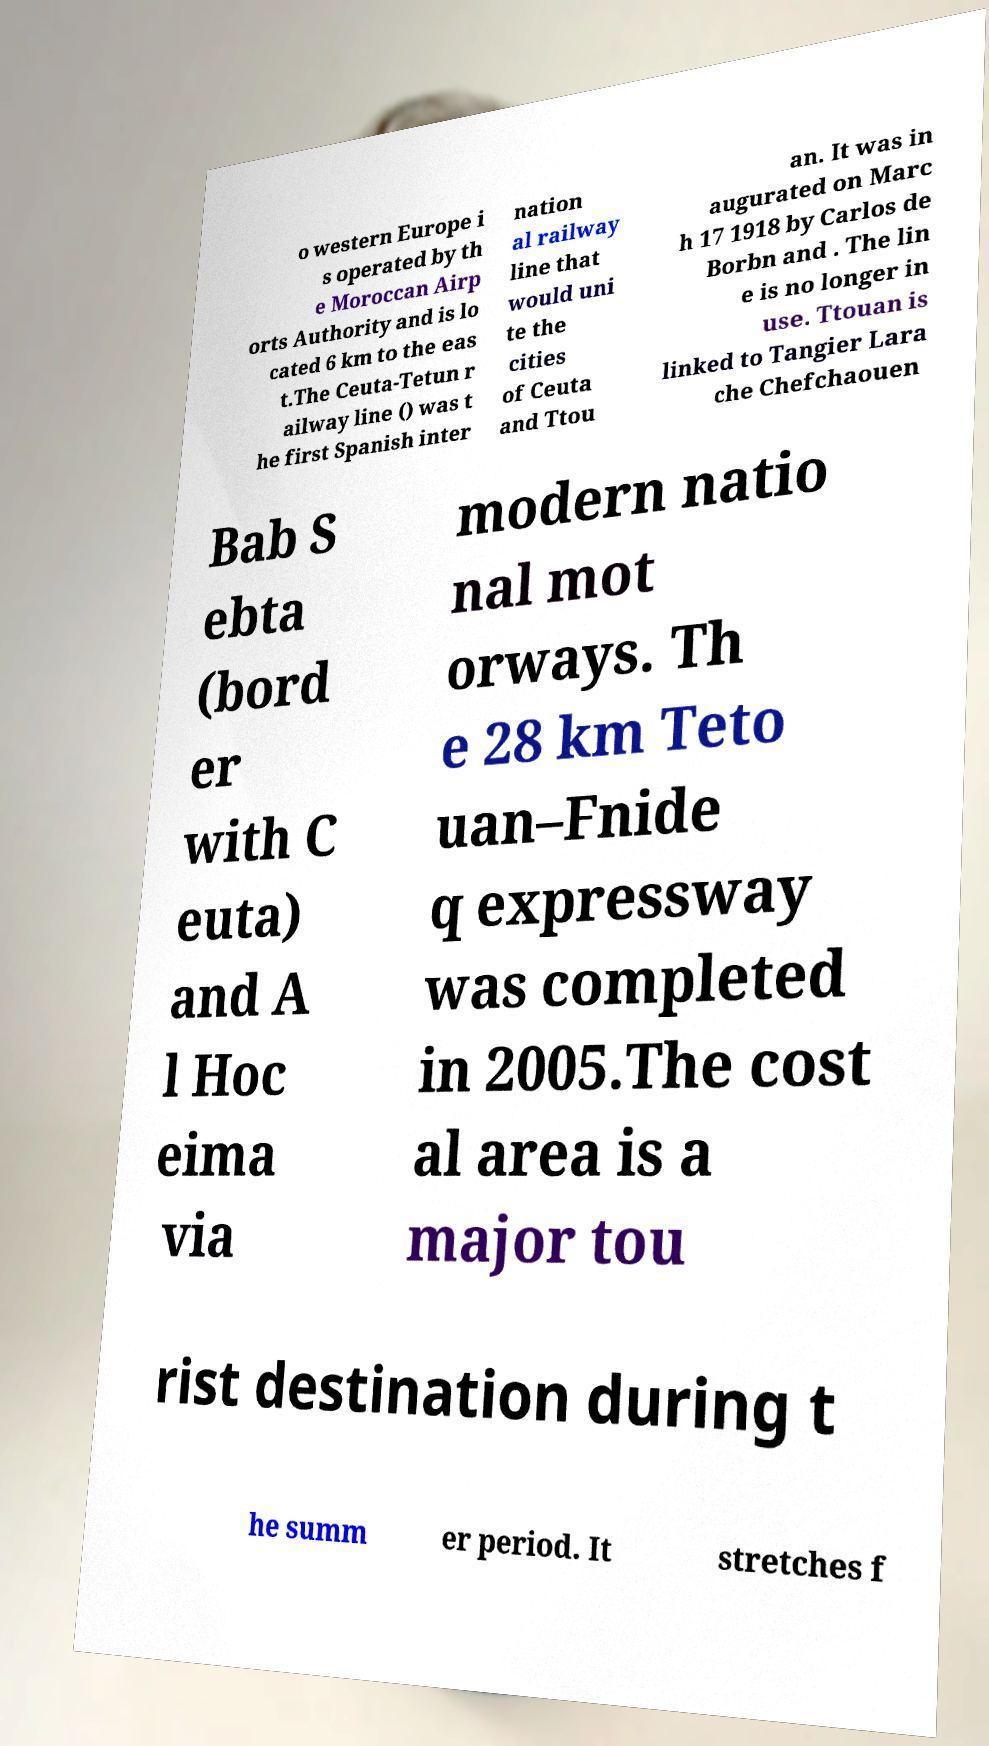For documentation purposes, I need the text within this image transcribed. Could you provide that? o western Europe i s operated by th e Moroccan Airp orts Authority and is lo cated 6 km to the eas t.The Ceuta-Tetun r ailway line () was t he first Spanish inter nation al railway line that would uni te the cities of Ceuta and Ttou an. It was in augurated on Marc h 17 1918 by Carlos de Borbn and . The lin e is no longer in use. Ttouan is linked to Tangier Lara che Chefchaouen Bab S ebta (bord er with C euta) and A l Hoc eima via modern natio nal mot orways. Th e 28 km Teto uan–Fnide q expressway was completed in 2005.The cost al area is a major tou rist destination during t he summ er period. It stretches f 